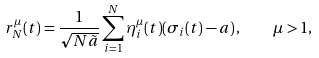<formula> <loc_0><loc_0><loc_500><loc_500>r _ { N } ^ { \mu } ( t ) = \frac { 1 } { \sqrt { N \tilde { a } } } \sum _ { i = 1 } ^ { N } { \eta _ { i } ^ { \mu } ( t ) } ( \sigma _ { i } ( t ) - a ) \, , \quad \mu > 1 ,</formula> 